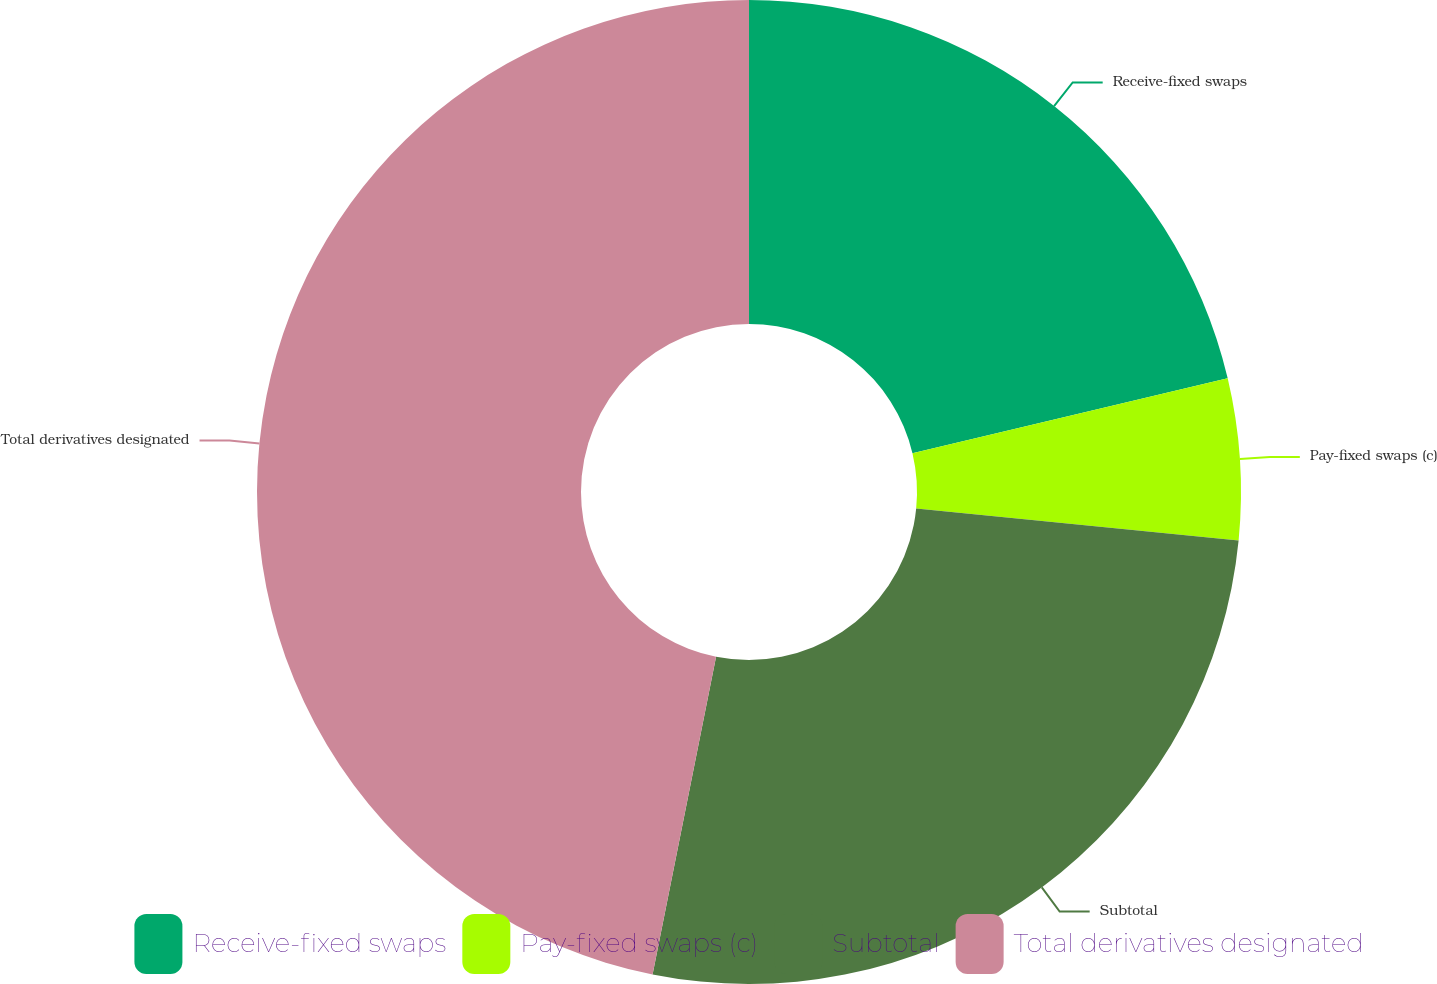<chart> <loc_0><loc_0><loc_500><loc_500><pie_chart><fcel>Receive-fixed swaps<fcel>Pay-fixed swaps (c)<fcel>Subtotal<fcel>Total derivatives designated<nl><fcel>21.29%<fcel>5.28%<fcel>26.57%<fcel>46.86%<nl></chart> 